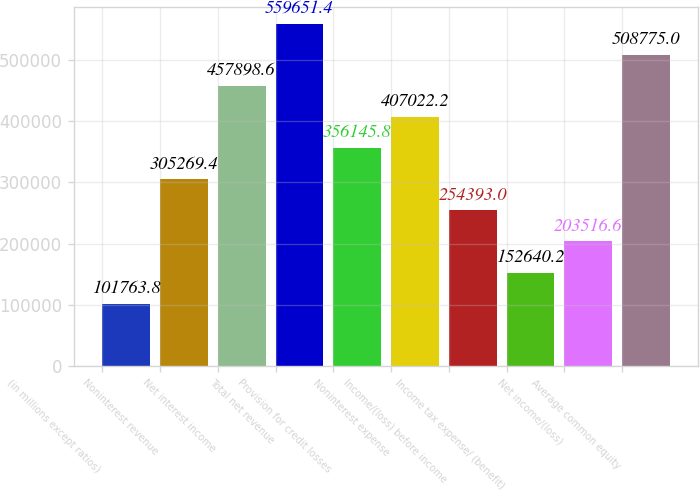<chart> <loc_0><loc_0><loc_500><loc_500><bar_chart><fcel>(in millions except ratios)<fcel>Noninterest revenue<fcel>Net interest income<fcel>Total net revenue<fcel>Provision for credit losses<fcel>Noninterest expense<fcel>Income/(loss) before income<fcel>Income tax expense/ (benefit)<fcel>Net income/(loss)<fcel>Average common equity<nl><fcel>101764<fcel>305269<fcel>457899<fcel>559651<fcel>356146<fcel>407022<fcel>254393<fcel>152640<fcel>203517<fcel>508775<nl></chart> 